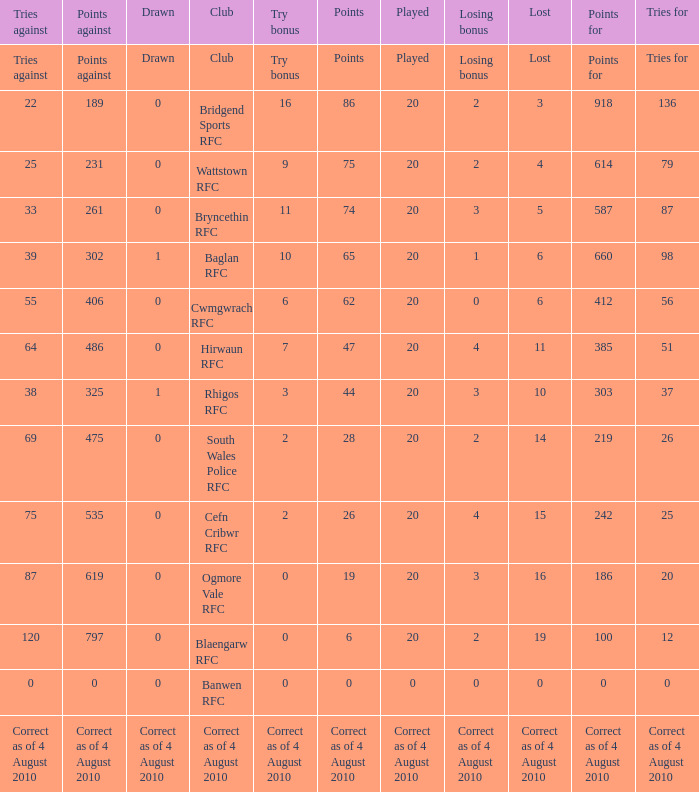What is the tries fow when losing bonus is losing bonus? Tries for. 